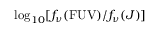<formula> <loc_0><loc_0><loc_500><loc_500>\log _ { 1 0 } [ f _ { \nu } ( F U V ) / f _ { \nu } ( J ) ]</formula> 